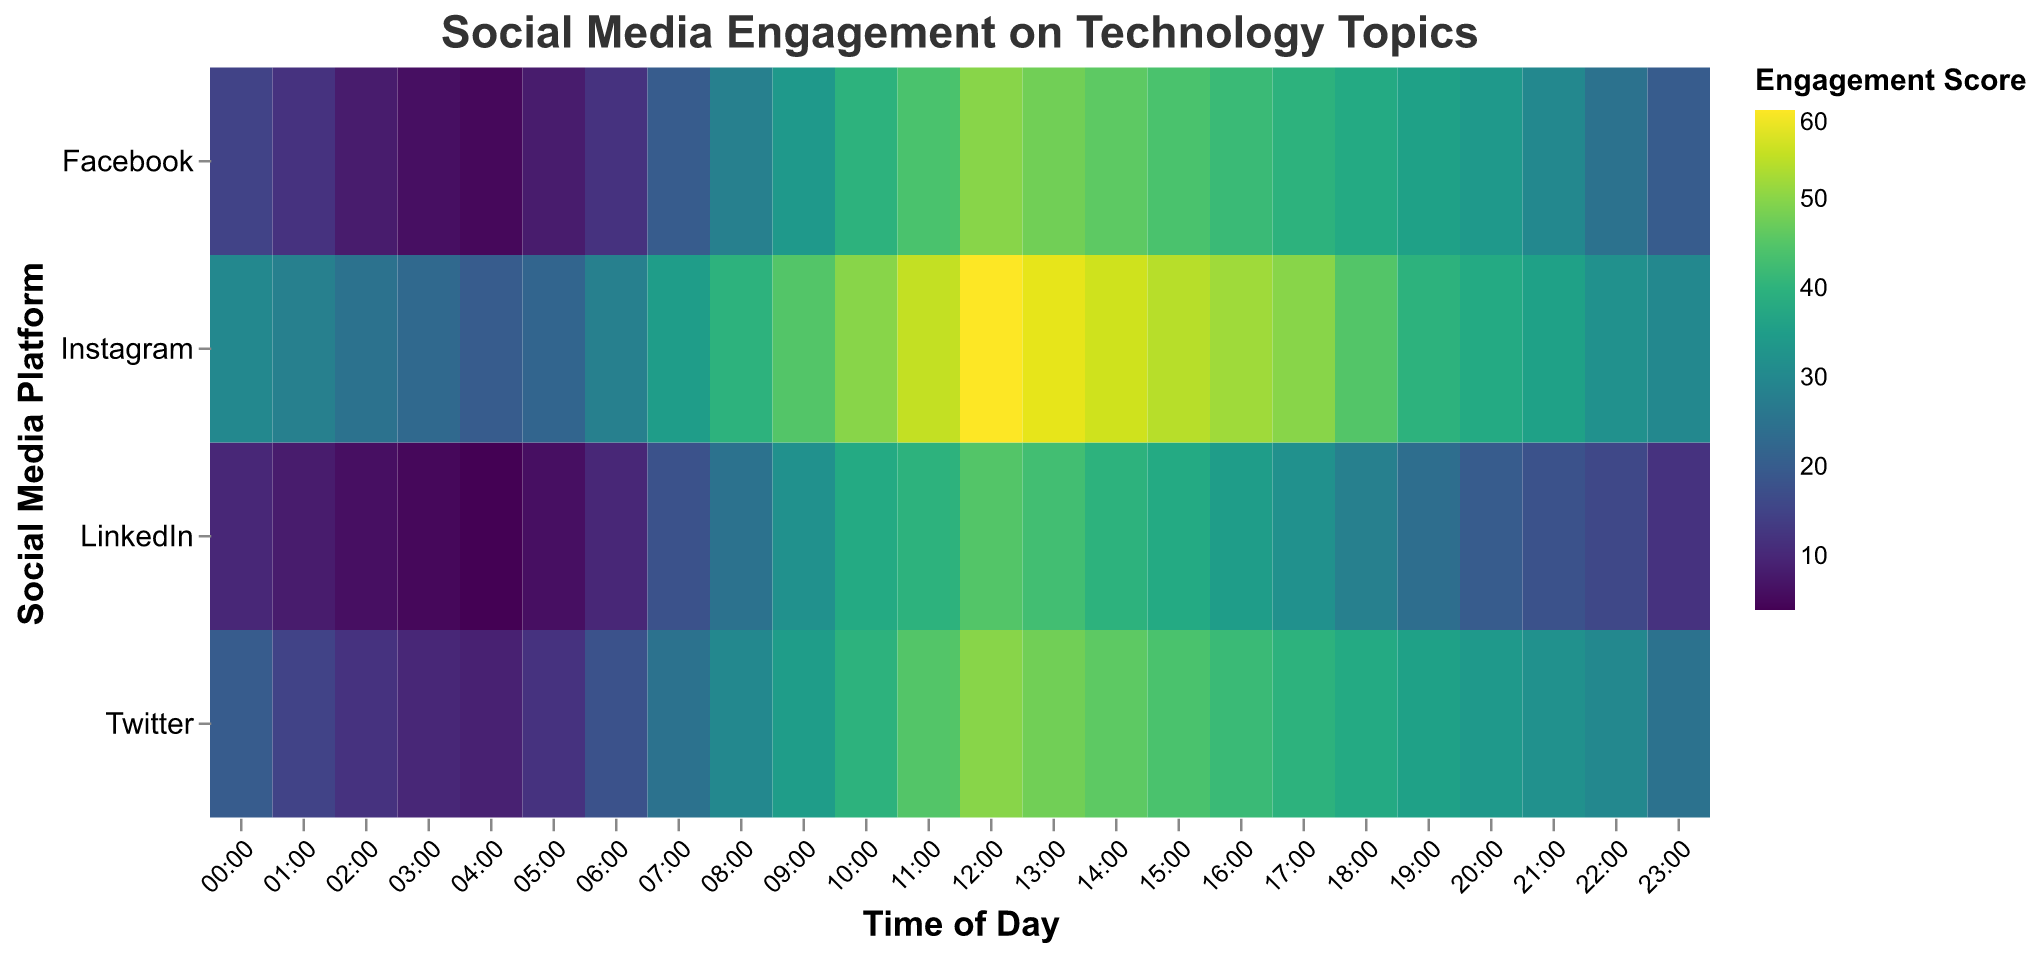What time of day has the highest engagement score on Instagram? Look for the highest value along the Instagram row and find the corresponding time on the x-axis. The highest value is 60, which corresponds to 12:00.
Answer: 12:00 Which platform has the highest engagement score in the morning (00:00 to 11:00)? Compare the engagement scores across all platforms during the time range 00:00 to 11:00. Instagram has the highest score at 11:00 with a value of 55.
Answer: Instagram During which time period does Facebook have the highest engagement score? Look for the highest value along the Facebook row and find the corresponding time on the x-axis. The highest value is 50, which occurs at 12:00.
Answer: 12:00 Which platform shows the lowest engagement score overall, and at what time? Identify the lowest engagement score value in the heatmap and find both the platform and the time for that value. The lowest value is 4 on LinkedIn at 04:00.
Answer: LinkedIn at 04:00 By how much does the engagement score on Twitter change from 06:00 to 09:00? Find the engagement scores on Twitter at 06:00 and 09:00, then compute the difference. Scores are 18 at 06:00 and 35 at 09:00, giving a change of 35 - 18 = 17.
Answer: 17 How does the engagement score at 08:00 compare between Facebook and LinkedIn? Identify the engagement scores at 08:00 for both Facebook and LinkedIn. Facebook has a score of 28, while LinkedIn has a score of 25. Thus, Facebook's score is higher by 3 points.
Answer: Facebook's score is higher by 3 points What is the average engagement score on LinkedIn between 12:00 and 15:00? Calculate the average of the engagement scores at 12:00, 13:00, 14:00, and 15:00 for LinkedIn. Scores are 45, 43, 40, and 38. Average = (45 + 43 + 40 + 38) / 4 = 166 / 4 = 41.5
Answer: 41.5 Which time frame has the most significant drop in engagement score on Twitter? Identify the time frame with the largest negative difference in engagement score by comparing consecutive hours. The most significant drop is from 12:00 to 13:00, from 50 to 48.
Answer: 12:00 to 13:00 Is there a time when all platforms have increased engagement scores? Because the heatmap shows a range of completed engagement at different times, look for a consistent increase, more notably in the middle parts of the day, generally around noon, where all platforms show increased engagement.
Answer: Around noon 